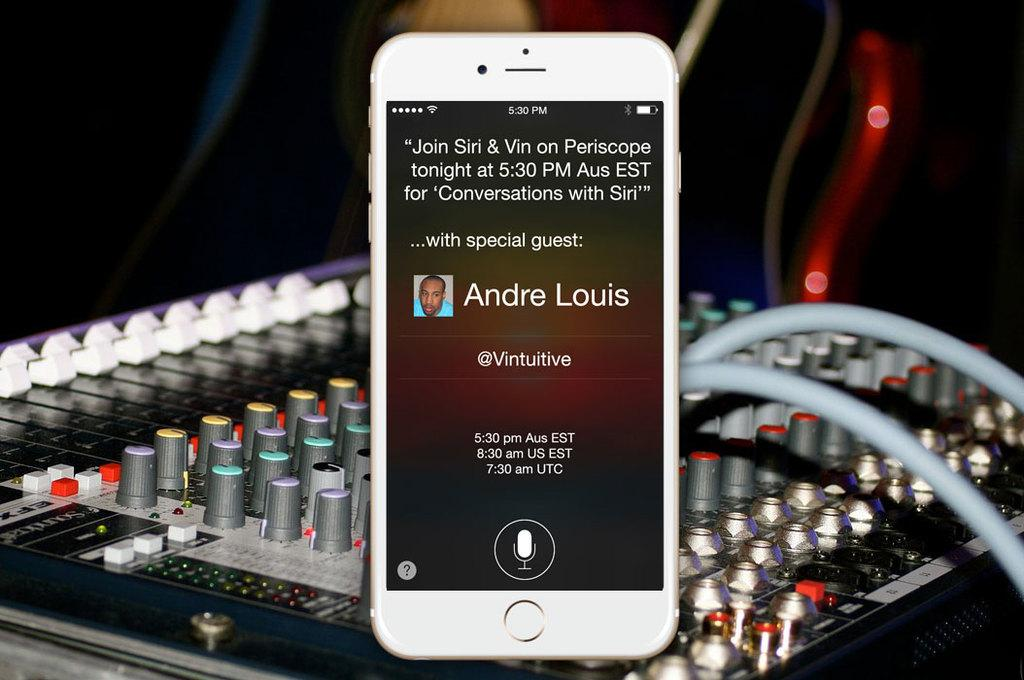<image>
Create a compact narrative representing the image presented. Andre Louis will be the guest tonight on Periscope at 5:30 pm. 